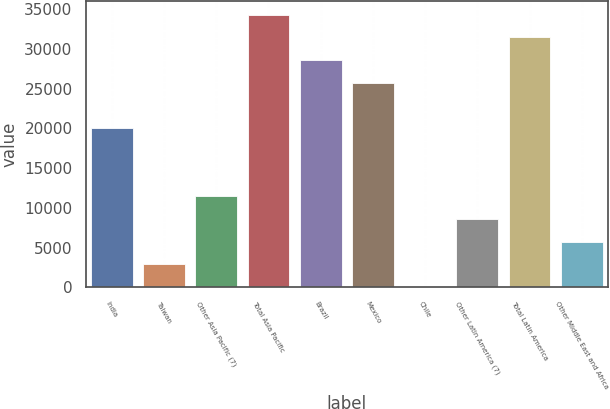Convert chart to OTSL. <chart><loc_0><loc_0><loc_500><loc_500><bar_chart><fcel>India<fcel>Taiwan<fcel>Other Asia Pacific (7)<fcel>Total Asia Pacific<fcel>Brazil<fcel>Mexico<fcel>Chile<fcel>Other Latin America (7)<fcel>Total Latin America<fcel>Other Middle East and Africa<nl><fcel>20020.8<fcel>2882.4<fcel>11451.6<fcel>34302.8<fcel>28590<fcel>25733.6<fcel>26<fcel>8595.2<fcel>31446.4<fcel>5738.8<nl></chart> 